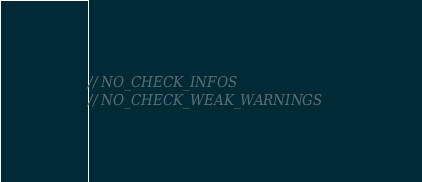Convert code to text. <code><loc_0><loc_0><loc_500><loc_500><_Kotlin_>
// NO_CHECK_INFOS
// NO_CHECK_WEAK_WARNINGS</code> 